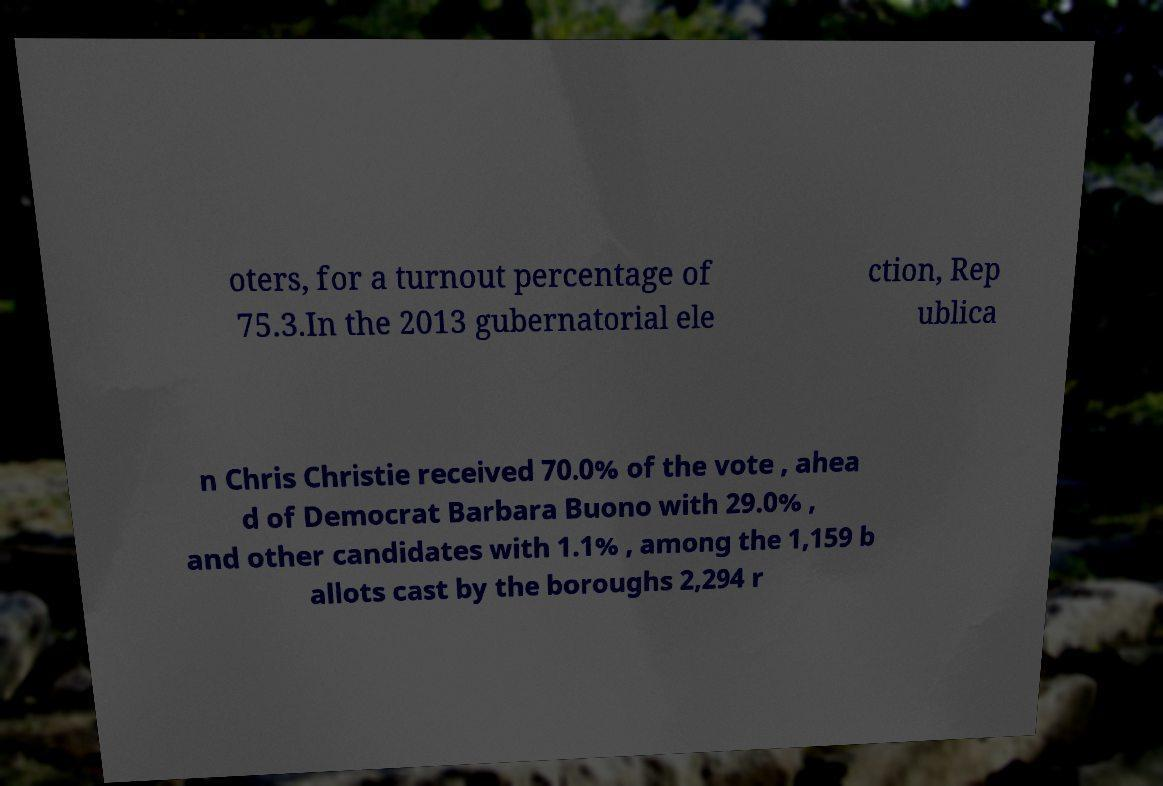Can you read and provide the text displayed in the image?This photo seems to have some interesting text. Can you extract and type it out for me? oters, for a turnout percentage of 75.3.In the 2013 gubernatorial ele ction, Rep ublica n Chris Christie received 70.0% of the vote , ahea d of Democrat Barbara Buono with 29.0% , and other candidates with 1.1% , among the 1,159 b allots cast by the boroughs 2,294 r 